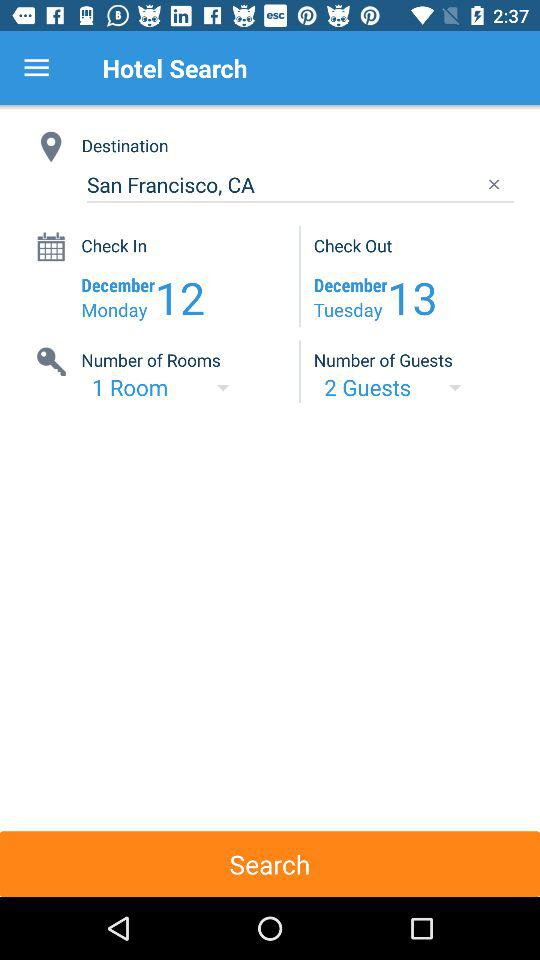What is the check-in date? The check-in date is Monday, December 12. 